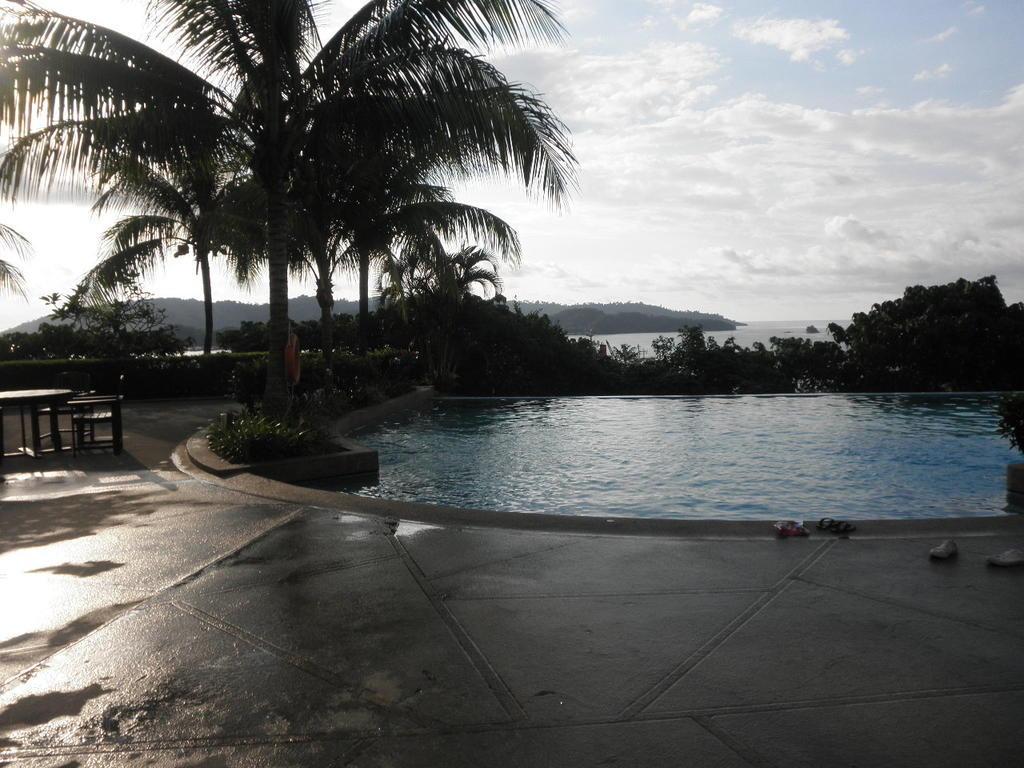Please provide a concise description of this image. There are chairs and a table on the left side of the image, it seems like a swimming pool and trees in the center. There is a water, greenery, it seems like mountains and the sky in the background. 